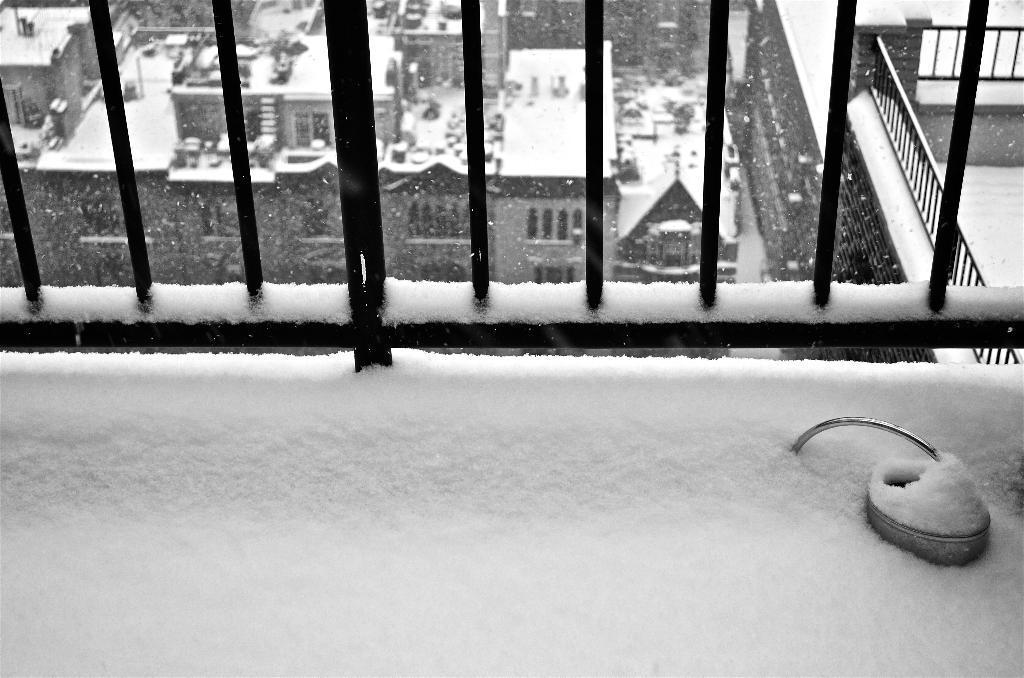How would you summarize this image in a sentence or two? In this picture we can see snow, few metal rods and buildings, it is a black and white photography. 